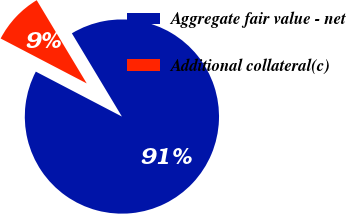Convert chart. <chart><loc_0><loc_0><loc_500><loc_500><pie_chart><fcel>Aggregate fair value - net<fcel>Additional collateral(c)<nl><fcel>91.27%<fcel>8.73%<nl></chart> 